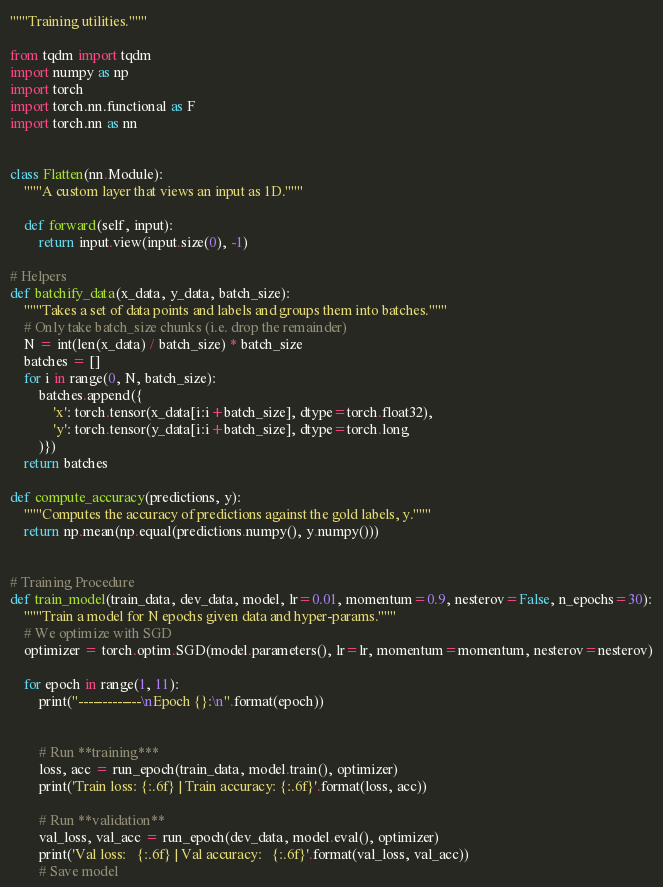<code> <loc_0><loc_0><loc_500><loc_500><_Python_>"""Training utilities."""

from tqdm import tqdm
import numpy as np
import torch
import torch.nn.functional as F
import torch.nn as nn


class Flatten(nn.Module):
    """A custom layer that views an input as 1D."""

    def forward(self, input):
        return input.view(input.size(0), -1)

# Helpers
def batchify_data(x_data, y_data, batch_size):
    """Takes a set of data points and labels and groups them into batches."""
    # Only take batch_size chunks (i.e. drop the remainder)
    N = int(len(x_data) / batch_size) * batch_size
    batches = []
    for i in range(0, N, batch_size):
        batches.append({
            'x': torch.tensor(x_data[i:i+batch_size], dtype=torch.float32),
            'y': torch.tensor(y_data[i:i+batch_size], dtype=torch.long
        )})
    return batches

def compute_accuracy(predictions, y):
    """Computes the accuracy of predictions against the gold labels, y."""
    return np.mean(np.equal(predictions.numpy(), y.numpy()))


# Training Procedure
def train_model(train_data, dev_data, model, lr=0.01, momentum=0.9, nesterov=False, n_epochs=30):
    """Train a model for N epochs given data and hyper-params."""
    # We optimize with SGD
    optimizer = torch.optim.SGD(model.parameters(), lr=lr, momentum=momentum, nesterov=nesterov)

    for epoch in range(1, 11):
        print("-------------\nEpoch {}:\n".format(epoch))


        # Run **training***
        loss, acc = run_epoch(train_data, model.train(), optimizer)
        print('Train loss: {:.6f} | Train accuracy: {:.6f}'.format(loss, acc))

        # Run **validation**
        val_loss, val_acc = run_epoch(dev_data, model.eval(), optimizer)
        print('Val loss:   {:.6f} | Val accuracy:   {:.6f}'.format(val_loss, val_acc))
        # Save model</code> 